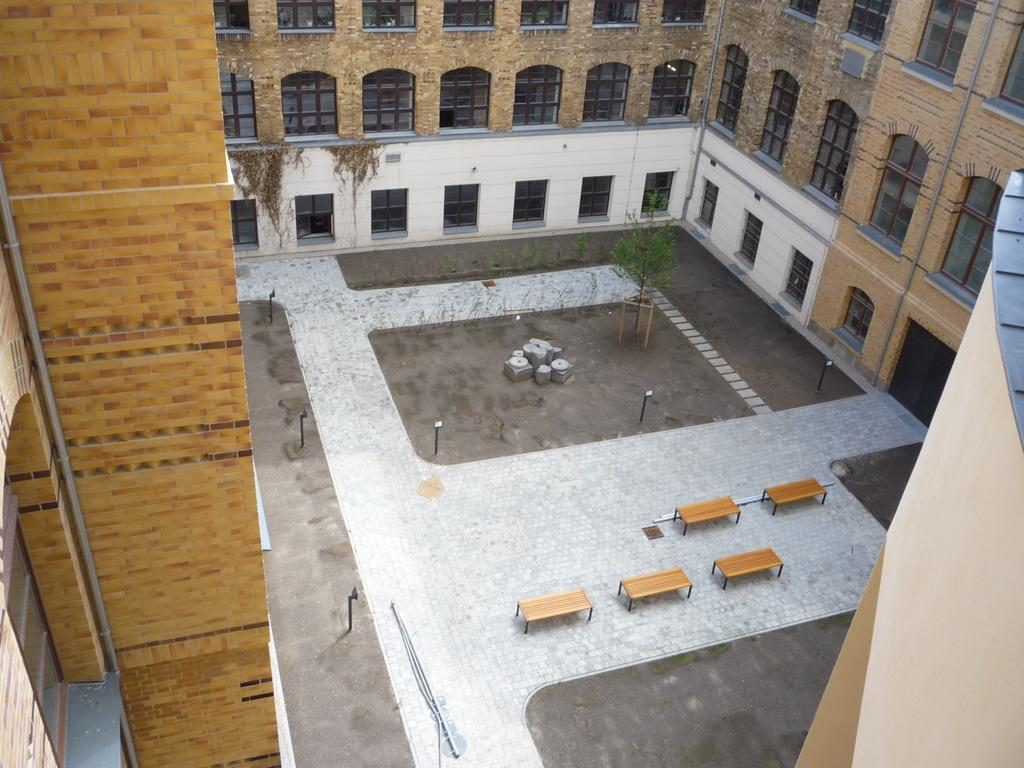What type of structure is present in the image? There is a building in the image. What feature can be seen on the building? The building has windows. What is visible beneath the building in the image? There is ground visible in the image. What type of seating is available on the ground? There are benches on the ground. What type of vegetation is present on the ground? There is a plant placed on the ground. What type of silk is draped over the government building in the image? There is no silk or government building mentioned in the image; it only features a building with windows and a ground with benches and a plant. 